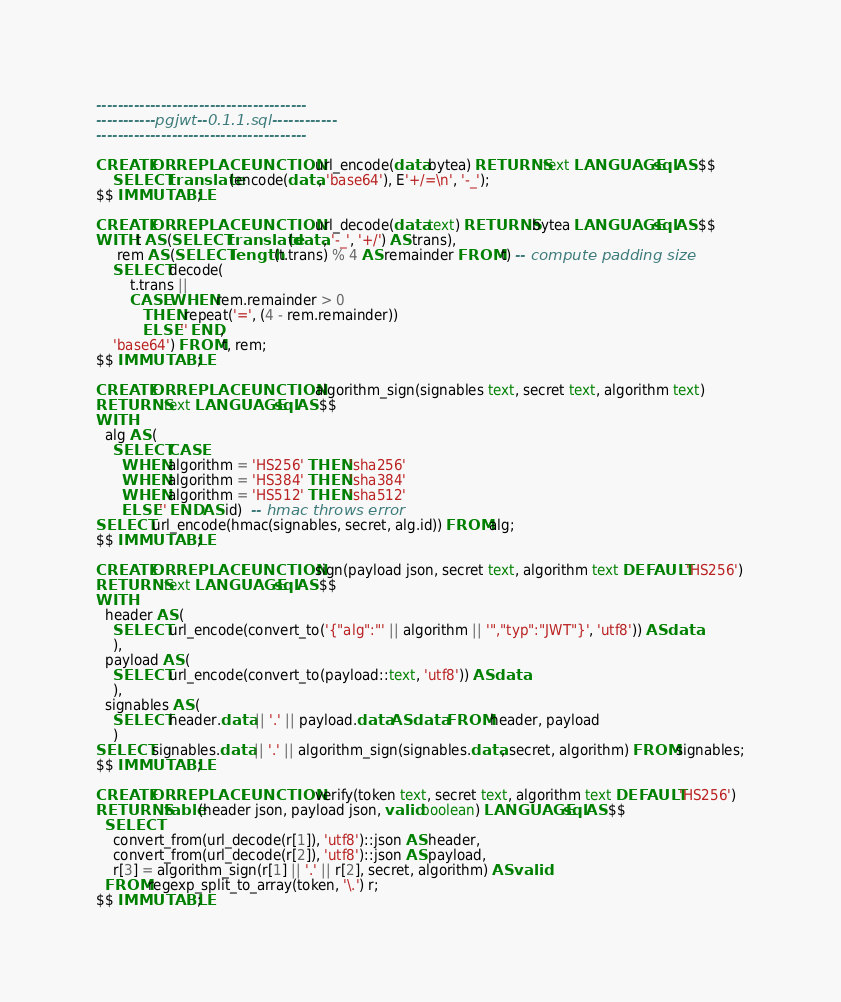<code> <loc_0><loc_0><loc_500><loc_500><_SQL_>---------------------------------------
-----------pgjwt--0.1.1.sql------------
---------------------------------------

CREATE OR REPLACE FUNCTION url_encode(data bytea) RETURNS text LANGUAGE sql AS $$
    SELECT translate(encode(data, 'base64'), E'+/=\n', '-_');
$$ IMMUTABLE;

CREATE OR REPLACE FUNCTION url_decode(data text) RETURNS bytea LANGUAGE sql AS $$
WITH t AS (SELECT translate(data, '-_', '+/') AS trans),
     rem AS (SELECT length(t.trans) % 4 AS remainder FROM t) -- compute padding size
    SELECT decode(
        t.trans ||
        CASE WHEN rem.remainder > 0
           THEN repeat('=', (4 - rem.remainder))
           ELSE '' END,
    'base64') FROM t, rem;
$$ IMMUTABLE;

CREATE OR REPLACE FUNCTION algorithm_sign(signables text, secret text, algorithm text)
RETURNS text LANGUAGE sql AS $$
WITH
  alg AS (
    SELECT CASE
      WHEN algorithm = 'HS256' THEN 'sha256'
      WHEN algorithm = 'HS384' THEN 'sha384'
      WHEN algorithm = 'HS512' THEN 'sha512'
      ELSE '' END AS id)  -- hmac throws error
SELECT url_encode(hmac(signables, secret, alg.id)) FROM alg;
$$ IMMUTABLE;

CREATE OR REPLACE FUNCTION sign(payload json, secret text, algorithm text DEFAULT 'HS256')
RETURNS text LANGUAGE sql AS $$
WITH
  header AS (
    SELECT url_encode(convert_to('{"alg":"' || algorithm || '","typ":"JWT"}', 'utf8')) AS data
    ),
  payload AS (
    SELECT url_encode(convert_to(payload::text, 'utf8')) AS data
    ),
  signables AS (
    SELECT header.data || '.' || payload.data AS data FROM header, payload
    )
SELECT signables.data || '.' || algorithm_sign(signables.data, secret, algorithm) FROM signables;
$$ IMMUTABLE;

CREATE OR REPLACE FUNCTION verify(token text, secret text, algorithm text DEFAULT 'HS256')
RETURNS table(header json, payload json, valid boolean) LANGUAGE sql AS $$
  SELECT
    convert_from(url_decode(r[1]), 'utf8')::json AS header,
    convert_from(url_decode(r[2]), 'utf8')::json AS payload,
    r[3] = algorithm_sign(r[1] || '.' || r[2], secret, algorithm) AS valid
  FROM regexp_split_to_array(token, '\.') r;
$$ IMMUTABLE;
</code> 